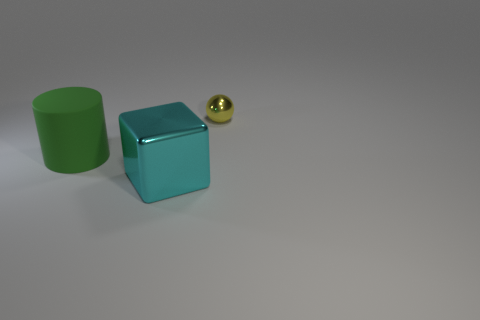Does the ball have the same color as the large cylinder?
Provide a short and direct response. No. How many large cubes have the same color as the big matte cylinder?
Give a very brief answer. 0. Do the metal thing that is in front of the yellow metallic object and the cylinder have the same color?
Offer a terse response. No. Is the number of big objects to the left of the big matte thing the same as the number of large cyan metal blocks left of the cyan shiny cube?
Provide a short and direct response. Yes. Is there anything else that has the same material as the yellow object?
Give a very brief answer. Yes. There is a metallic thing that is in front of the small sphere; what is its color?
Give a very brief answer. Cyan. Are there an equal number of small yellow metallic objects behind the yellow thing and green shiny cylinders?
Provide a succinct answer. Yes. How many other objects are there of the same shape as the green thing?
Your answer should be compact. 0. How many green cylinders are to the left of the green thing?
Offer a terse response. 0. What is the size of the object that is both in front of the yellow metal ball and behind the cyan shiny cube?
Give a very brief answer. Large. 